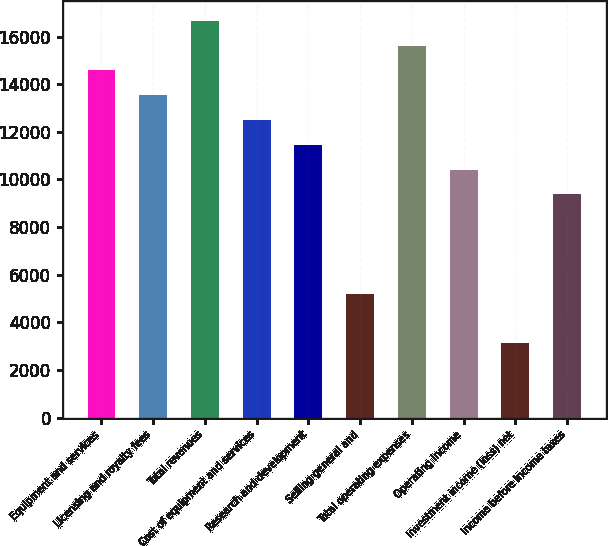<chart> <loc_0><loc_0><loc_500><loc_500><bar_chart><fcel>Equipment and services<fcel>Licensing and royalty fees<fcel>Total revenues<fcel>Cost of equipment and services<fcel>Research and development<fcel>Selling general and<fcel>Total operating expenses<fcel>Operating income<fcel>Investment income (loss) net<fcel>Income before income taxes<nl><fcel>14582.1<fcel>13540.5<fcel>16665.1<fcel>12499<fcel>11457.5<fcel>5208.31<fcel>15623.6<fcel>10416<fcel>3125.25<fcel>9374.43<nl></chart> 